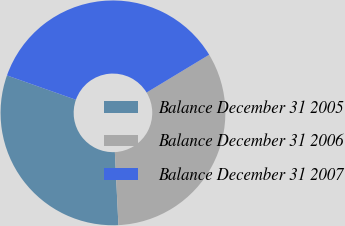Convert chart to OTSL. <chart><loc_0><loc_0><loc_500><loc_500><pie_chart><fcel>Balance December 31 2005<fcel>Balance December 31 2006<fcel>Balance December 31 2007<nl><fcel>31.18%<fcel>32.88%<fcel>35.95%<nl></chart> 